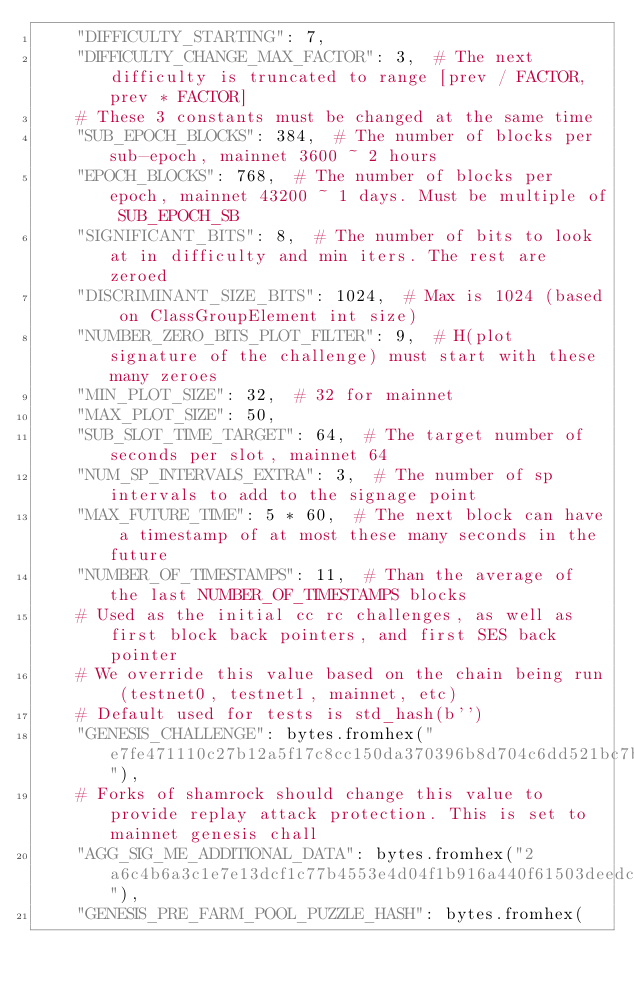Convert code to text. <code><loc_0><loc_0><loc_500><loc_500><_Python_>    "DIFFICULTY_STARTING": 7,
    "DIFFICULTY_CHANGE_MAX_FACTOR": 3,  # The next difficulty is truncated to range [prev / FACTOR, prev * FACTOR]
    # These 3 constants must be changed at the same time
    "SUB_EPOCH_BLOCKS": 384,  # The number of blocks per sub-epoch, mainnet 3600 ~ 2 hours
    "EPOCH_BLOCKS": 768,  # The number of blocks per epoch, mainnet 43200 ~ 1 days. Must be multiple of SUB_EPOCH_SB
    "SIGNIFICANT_BITS": 8,  # The number of bits to look at in difficulty and min iters. The rest are zeroed
    "DISCRIMINANT_SIZE_BITS": 1024,  # Max is 1024 (based on ClassGroupElement int size)
    "NUMBER_ZERO_BITS_PLOT_FILTER": 9,  # H(plot signature of the challenge) must start with these many zeroes
    "MIN_PLOT_SIZE": 32,  # 32 for mainnet
    "MAX_PLOT_SIZE": 50,
    "SUB_SLOT_TIME_TARGET": 64,  # The target number of seconds per slot, mainnet 64
    "NUM_SP_INTERVALS_EXTRA": 3,  # The number of sp intervals to add to the signage point
    "MAX_FUTURE_TIME": 5 * 60,  # The next block can have a timestamp of at most these many seconds in the future
    "NUMBER_OF_TIMESTAMPS": 11,  # Than the average of the last NUMBER_OF_TIMESTAMPS blocks
    # Used as the initial cc rc challenges, as well as first block back pointers, and first SES back pointer
    # We override this value based on the chain being run (testnet0, testnet1, mainnet, etc)
    # Default used for tests is std_hash(b'')
    "GENESIS_CHALLENGE": bytes.fromhex("e7fe471110c27b12a5f17c8cc150da370396b8d704c6dd521bc7be99d4f358f6"),
    # Forks of shamrock should change this value to provide replay attack protection. This is set to mainnet genesis chall
    "AGG_SIG_ME_ADDITIONAL_DATA": bytes.fromhex("2a6c4b6a3c1e7e13dcf1c77b4553e4d04f1b916a440f61503deedc0899490529"),
    "GENESIS_PRE_FARM_POOL_PUZZLE_HASH": bytes.fromhex(</code> 